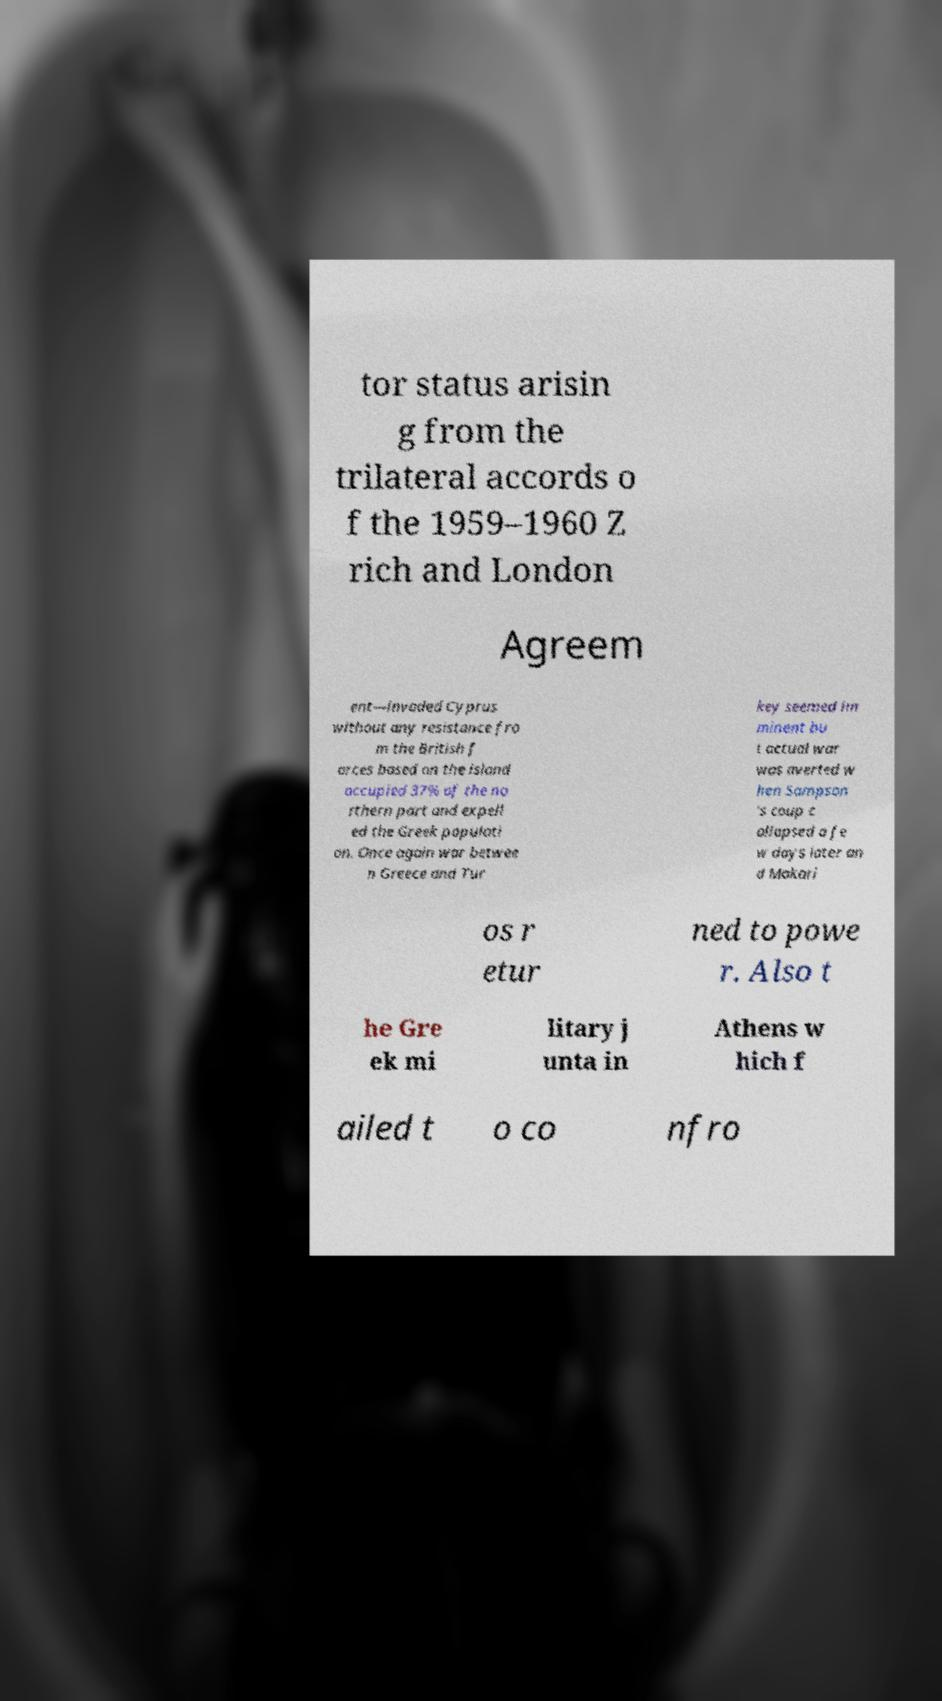What messages or text are displayed in this image? I need them in a readable, typed format. tor status arisin g from the trilateral accords o f the 1959–1960 Z rich and London Agreem ent—invaded Cyprus without any resistance fro m the British f orces based on the island occupied 37% of the no rthern part and expell ed the Greek populati on. Once again war betwee n Greece and Tur key seemed im minent bu t actual war was averted w hen Sampson 's coup c ollapsed a fe w days later an d Makari os r etur ned to powe r. Also t he Gre ek mi litary j unta in Athens w hich f ailed t o co nfro 